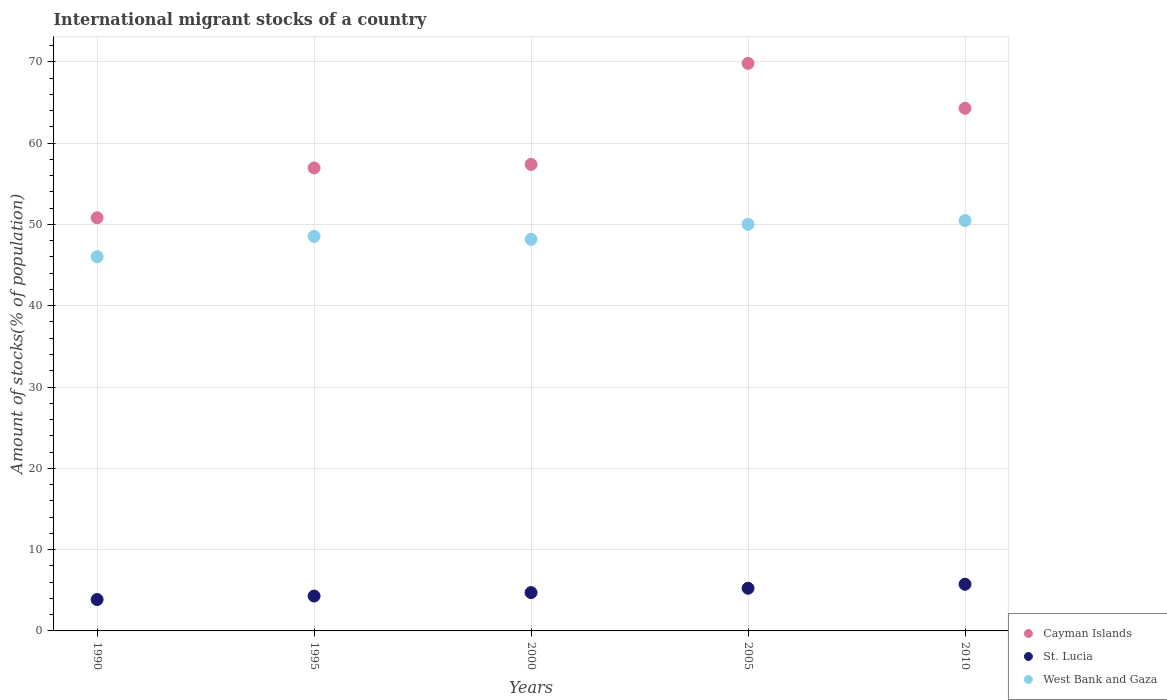Is the number of dotlines equal to the number of legend labels?
Provide a short and direct response. Yes. What is the amount of stocks in in West Bank and Gaza in 1995?
Keep it short and to the point. 48.53. Across all years, what is the maximum amount of stocks in in St. Lucia?
Offer a very short reply. 5.74. Across all years, what is the minimum amount of stocks in in St. Lucia?
Make the answer very short. 3.86. In which year was the amount of stocks in in Cayman Islands minimum?
Give a very brief answer. 1990. What is the total amount of stocks in in St. Lucia in the graph?
Keep it short and to the point. 23.85. What is the difference between the amount of stocks in in St. Lucia in 2000 and that in 2010?
Provide a succinct answer. -1.02. What is the difference between the amount of stocks in in St. Lucia in 2005 and the amount of stocks in in West Bank and Gaza in 2010?
Keep it short and to the point. -45.23. What is the average amount of stocks in in West Bank and Gaza per year?
Offer a terse response. 48.64. In the year 2010, what is the difference between the amount of stocks in in St. Lucia and amount of stocks in in West Bank and Gaza?
Your answer should be very brief. -44.74. In how many years, is the amount of stocks in in West Bank and Gaza greater than 12 %?
Your answer should be very brief. 5. What is the ratio of the amount of stocks in in Cayman Islands in 2000 to that in 2010?
Your answer should be very brief. 0.89. Is the difference between the amount of stocks in in St. Lucia in 1995 and 2010 greater than the difference between the amount of stocks in in West Bank and Gaza in 1995 and 2010?
Your answer should be compact. Yes. What is the difference between the highest and the second highest amount of stocks in in Cayman Islands?
Offer a very short reply. 5.53. What is the difference between the highest and the lowest amount of stocks in in Cayman Islands?
Provide a short and direct response. 18.98. Is it the case that in every year, the sum of the amount of stocks in in St. Lucia and amount of stocks in in West Bank and Gaza  is greater than the amount of stocks in in Cayman Islands?
Keep it short and to the point. No. Does the amount of stocks in in St. Lucia monotonically increase over the years?
Your response must be concise. Yes. Is the amount of stocks in in West Bank and Gaza strictly less than the amount of stocks in in Cayman Islands over the years?
Keep it short and to the point. Yes. How many years are there in the graph?
Your answer should be very brief. 5. What is the difference between two consecutive major ticks on the Y-axis?
Give a very brief answer. 10. Are the values on the major ticks of Y-axis written in scientific E-notation?
Provide a short and direct response. No. Does the graph contain any zero values?
Provide a succinct answer. No. Does the graph contain grids?
Offer a terse response. Yes. How many legend labels are there?
Offer a very short reply. 3. What is the title of the graph?
Offer a very short reply. International migrant stocks of a country. Does "Mozambique" appear as one of the legend labels in the graph?
Your answer should be very brief. No. What is the label or title of the X-axis?
Provide a short and direct response. Years. What is the label or title of the Y-axis?
Give a very brief answer. Amount of stocks(% of population). What is the Amount of stocks(% of population) of Cayman Islands in 1990?
Give a very brief answer. 50.83. What is the Amount of stocks(% of population) in St. Lucia in 1990?
Your answer should be compact. 3.86. What is the Amount of stocks(% of population) of West Bank and Gaza in 1990?
Offer a terse response. 46.03. What is the Amount of stocks(% of population) of Cayman Islands in 1995?
Your answer should be very brief. 56.95. What is the Amount of stocks(% of population) of St. Lucia in 1995?
Keep it short and to the point. 4.29. What is the Amount of stocks(% of population) in West Bank and Gaza in 1995?
Your answer should be compact. 48.53. What is the Amount of stocks(% of population) in Cayman Islands in 2000?
Your answer should be compact. 57.38. What is the Amount of stocks(% of population) of St. Lucia in 2000?
Give a very brief answer. 4.71. What is the Amount of stocks(% of population) of West Bank and Gaza in 2000?
Offer a terse response. 48.17. What is the Amount of stocks(% of population) of Cayman Islands in 2005?
Make the answer very short. 69.81. What is the Amount of stocks(% of population) in St. Lucia in 2005?
Provide a succinct answer. 5.25. What is the Amount of stocks(% of population) in West Bank and Gaza in 2005?
Offer a very short reply. 50.01. What is the Amount of stocks(% of population) in Cayman Islands in 2010?
Your response must be concise. 64.29. What is the Amount of stocks(% of population) of St. Lucia in 2010?
Your answer should be very brief. 5.74. What is the Amount of stocks(% of population) in West Bank and Gaza in 2010?
Your response must be concise. 50.48. Across all years, what is the maximum Amount of stocks(% of population) in Cayman Islands?
Your answer should be very brief. 69.81. Across all years, what is the maximum Amount of stocks(% of population) in St. Lucia?
Your response must be concise. 5.74. Across all years, what is the maximum Amount of stocks(% of population) in West Bank and Gaza?
Give a very brief answer. 50.48. Across all years, what is the minimum Amount of stocks(% of population) in Cayman Islands?
Offer a very short reply. 50.83. Across all years, what is the minimum Amount of stocks(% of population) in St. Lucia?
Ensure brevity in your answer.  3.86. Across all years, what is the minimum Amount of stocks(% of population) of West Bank and Gaza?
Provide a short and direct response. 46.03. What is the total Amount of stocks(% of population) of Cayman Islands in the graph?
Keep it short and to the point. 299.25. What is the total Amount of stocks(% of population) of St. Lucia in the graph?
Keep it short and to the point. 23.85. What is the total Amount of stocks(% of population) of West Bank and Gaza in the graph?
Offer a terse response. 243.22. What is the difference between the Amount of stocks(% of population) in Cayman Islands in 1990 and that in 1995?
Keep it short and to the point. -6.12. What is the difference between the Amount of stocks(% of population) of St. Lucia in 1990 and that in 1995?
Offer a terse response. -0.43. What is the difference between the Amount of stocks(% of population) in West Bank and Gaza in 1990 and that in 1995?
Make the answer very short. -2.5. What is the difference between the Amount of stocks(% of population) in Cayman Islands in 1990 and that in 2000?
Keep it short and to the point. -6.56. What is the difference between the Amount of stocks(% of population) of St. Lucia in 1990 and that in 2000?
Offer a terse response. -0.85. What is the difference between the Amount of stocks(% of population) in West Bank and Gaza in 1990 and that in 2000?
Keep it short and to the point. -2.14. What is the difference between the Amount of stocks(% of population) of Cayman Islands in 1990 and that in 2005?
Make the answer very short. -18.98. What is the difference between the Amount of stocks(% of population) in St. Lucia in 1990 and that in 2005?
Offer a very short reply. -1.39. What is the difference between the Amount of stocks(% of population) in West Bank and Gaza in 1990 and that in 2005?
Your answer should be very brief. -3.98. What is the difference between the Amount of stocks(% of population) in Cayman Islands in 1990 and that in 2010?
Provide a succinct answer. -13.46. What is the difference between the Amount of stocks(% of population) in St. Lucia in 1990 and that in 2010?
Your response must be concise. -1.88. What is the difference between the Amount of stocks(% of population) of West Bank and Gaza in 1990 and that in 2010?
Provide a short and direct response. -4.45. What is the difference between the Amount of stocks(% of population) in Cayman Islands in 1995 and that in 2000?
Your response must be concise. -0.43. What is the difference between the Amount of stocks(% of population) of St. Lucia in 1995 and that in 2000?
Your answer should be compact. -0.42. What is the difference between the Amount of stocks(% of population) in West Bank and Gaza in 1995 and that in 2000?
Ensure brevity in your answer.  0.36. What is the difference between the Amount of stocks(% of population) in Cayman Islands in 1995 and that in 2005?
Give a very brief answer. -12.86. What is the difference between the Amount of stocks(% of population) in St. Lucia in 1995 and that in 2005?
Offer a terse response. -0.96. What is the difference between the Amount of stocks(% of population) of West Bank and Gaza in 1995 and that in 2005?
Make the answer very short. -1.48. What is the difference between the Amount of stocks(% of population) of Cayman Islands in 1995 and that in 2010?
Provide a succinct answer. -7.34. What is the difference between the Amount of stocks(% of population) in St. Lucia in 1995 and that in 2010?
Offer a terse response. -1.45. What is the difference between the Amount of stocks(% of population) of West Bank and Gaza in 1995 and that in 2010?
Your answer should be very brief. -1.95. What is the difference between the Amount of stocks(% of population) of Cayman Islands in 2000 and that in 2005?
Make the answer very short. -12.43. What is the difference between the Amount of stocks(% of population) of St. Lucia in 2000 and that in 2005?
Your answer should be compact. -0.53. What is the difference between the Amount of stocks(% of population) in West Bank and Gaza in 2000 and that in 2005?
Your response must be concise. -1.84. What is the difference between the Amount of stocks(% of population) of Cayman Islands in 2000 and that in 2010?
Your response must be concise. -6.9. What is the difference between the Amount of stocks(% of population) in St. Lucia in 2000 and that in 2010?
Keep it short and to the point. -1.02. What is the difference between the Amount of stocks(% of population) of West Bank and Gaza in 2000 and that in 2010?
Ensure brevity in your answer.  -2.31. What is the difference between the Amount of stocks(% of population) of Cayman Islands in 2005 and that in 2010?
Your answer should be very brief. 5.53. What is the difference between the Amount of stocks(% of population) of St. Lucia in 2005 and that in 2010?
Provide a succinct answer. -0.49. What is the difference between the Amount of stocks(% of population) of West Bank and Gaza in 2005 and that in 2010?
Ensure brevity in your answer.  -0.47. What is the difference between the Amount of stocks(% of population) of Cayman Islands in 1990 and the Amount of stocks(% of population) of St. Lucia in 1995?
Your answer should be very brief. 46.53. What is the difference between the Amount of stocks(% of population) in Cayman Islands in 1990 and the Amount of stocks(% of population) in West Bank and Gaza in 1995?
Offer a terse response. 2.29. What is the difference between the Amount of stocks(% of population) in St. Lucia in 1990 and the Amount of stocks(% of population) in West Bank and Gaza in 1995?
Your response must be concise. -44.67. What is the difference between the Amount of stocks(% of population) of Cayman Islands in 1990 and the Amount of stocks(% of population) of St. Lucia in 2000?
Provide a short and direct response. 46.11. What is the difference between the Amount of stocks(% of population) in Cayman Islands in 1990 and the Amount of stocks(% of population) in West Bank and Gaza in 2000?
Offer a terse response. 2.65. What is the difference between the Amount of stocks(% of population) of St. Lucia in 1990 and the Amount of stocks(% of population) of West Bank and Gaza in 2000?
Your answer should be compact. -44.31. What is the difference between the Amount of stocks(% of population) in Cayman Islands in 1990 and the Amount of stocks(% of population) in St. Lucia in 2005?
Your response must be concise. 45.58. What is the difference between the Amount of stocks(% of population) in Cayman Islands in 1990 and the Amount of stocks(% of population) in West Bank and Gaza in 2005?
Keep it short and to the point. 0.81. What is the difference between the Amount of stocks(% of population) of St. Lucia in 1990 and the Amount of stocks(% of population) of West Bank and Gaza in 2005?
Keep it short and to the point. -46.15. What is the difference between the Amount of stocks(% of population) in Cayman Islands in 1990 and the Amount of stocks(% of population) in St. Lucia in 2010?
Offer a very short reply. 45.09. What is the difference between the Amount of stocks(% of population) of Cayman Islands in 1990 and the Amount of stocks(% of population) of West Bank and Gaza in 2010?
Provide a short and direct response. 0.35. What is the difference between the Amount of stocks(% of population) in St. Lucia in 1990 and the Amount of stocks(% of population) in West Bank and Gaza in 2010?
Offer a terse response. -46.62. What is the difference between the Amount of stocks(% of population) in Cayman Islands in 1995 and the Amount of stocks(% of population) in St. Lucia in 2000?
Provide a succinct answer. 52.23. What is the difference between the Amount of stocks(% of population) of Cayman Islands in 1995 and the Amount of stocks(% of population) of West Bank and Gaza in 2000?
Ensure brevity in your answer.  8.78. What is the difference between the Amount of stocks(% of population) in St. Lucia in 1995 and the Amount of stocks(% of population) in West Bank and Gaza in 2000?
Ensure brevity in your answer.  -43.88. What is the difference between the Amount of stocks(% of population) in Cayman Islands in 1995 and the Amount of stocks(% of population) in St. Lucia in 2005?
Your answer should be very brief. 51.7. What is the difference between the Amount of stocks(% of population) of Cayman Islands in 1995 and the Amount of stocks(% of population) of West Bank and Gaza in 2005?
Provide a succinct answer. 6.94. What is the difference between the Amount of stocks(% of population) of St. Lucia in 1995 and the Amount of stocks(% of population) of West Bank and Gaza in 2005?
Offer a terse response. -45.72. What is the difference between the Amount of stocks(% of population) of Cayman Islands in 1995 and the Amount of stocks(% of population) of St. Lucia in 2010?
Offer a terse response. 51.21. What is the difference between the Amount of stocks(% of population) of Cayman Islands in 1995 and the Amount of stocks(% of population) of West Bank and Gaza in 2010?
Ensure brevity in your answer.  6.47. What is the difference between the Amount of stocks(% of population) of St. Lucia in 1995 and the Amount of stocks(% of population) of West Bank and Gaza in 2010?
Your response must be concise. -46.19. What is the difference between the Amount of stocks(% of population) of Cayman Islands in 2000 and the Amount of stocks(% of population) of St. Lucia in 2005?
Provide a succinct answer. 52.14. What is the difference between the Amount of stocks(% of population) in Cayman Islands in 2000 and the Amount of stocks(% of population) in West Bank and Gaza in 2005?
Offer a terse response. 7.37. What is the difference between the Amount of stocks(% of population) of St. Lucia in 2000 and the Amount of stocks(% of population) of West Bank and Gaza in 2005?
Provide a succinct answer. -45.3. What is the difference between the Amount of stocks(% of population) in Cayman Islands in 2000 and the Amount of stocks(% of population) in St. Lucia in 2010?
Offer a terse response. 51.64. What is the difference between the Amount of stocks(% of population) of Cayman Islands in 2000 and the Amount of stocks(% of population) of West Bank and Gaza in 2010?
Ensure brevity in your answer.  6.9. What is the difference between the Amount of stocks(% of population) of St. Lucia in 2000 and the Amount of stocks(% of population) of West Bank and Gaza in 2010?
Give a very brief answer. -45.76. What is the difference between the Amount of stocks(% of population) of Cayman Islands in 2005 and the Amount of stocks(% of population) of St. Lucia in 2010?
Ensure brevity in your answer.  64.07. What is the difference between the Amount of stocks(% of population) in Cayman Islands in 2005 and the Amount of stocks(% of population) in West Bank and Gaza in 2010?
Offer a very short reply. 19.33. What is the difference between the Amount of stocks(% of population) in St. Lucia in 2005 and the Amount of stocks(% of population) in West Bank and Gaza in 2010?
Provide a succinct answer. -45.23. What is the average Amount of stocks(% of population) of Cayman Islands per year?
Provide a succinct answer. 59.85. What is the average Amount of stocks(% of population) in St. Lucia per year?
Make the answer very short. 4.77. What is the average Amount of stocks(% of population) in West Bank and Gaza per year?
Give a very brief answer. 48.64. In the year 1990, what is the difference between the Amount of stocks(% of population) of Cayman Islands and Amount of stocks(% of population) of St. Lucia?
Offer a terse response. 46.96. In the year 1990, what is the difference between the Amount of stocks(% of population) in Cayman Islands and Amount of stocks(% of population) in West Bank and Gaza?
Make the answer very short. 4.79. In the year 1990, what is the difference between the Amount of stocks(% of population) of St. Lucia and Amount of stocks(% of population) of West Bank and Gaza?
Offer a terse response. -42.17. In the year 1995, what is the difference between the Amount of stocks(% of population) of Cayman Islands and Amount of stocks(% of population) of St. Lucia?
Offer a very short reply. 52.66. In the year 1995, what is the difference between the Amount of stocks(% of population) of Cayman Islands and Amount of stocks(% of population) of West Bank and Gaza?
Give a very brief answer. 8.42. In the year 1995, what is the difference between the Amount of stocks(% of population) of St. Lucia and Amount of stocks(% of population) of West Bank and Gaza?
Give a very brief answer. -44.24. In the year 2000, what is the difference between the Amount of stocks(% of population) of Cayman Islands and Amount of stocks(% of population) of St. Lucia?
Your response must be concise. 52.67. In the year 2000, what is the difference between the Amount of stocks(% of population) of Cayman Islands and Amount of stocks(% of population) of West Bank and Gaza?
Offer a terse response. 9.21. In the year 2000, what is the difference between the Amount of stocks(% of population) in St. Lucia and Amount of stocks(% of population) in West Bank and Gaza?
Your answer should be very brief. -43.46. In the year 2005, what is the difference between the Amount of stocks(% of population) in Cayman Islands and Amount of stocks(% of population) in St. Lucia?
Offer a terse response. 64.56. In the year 2005, what is the difference between the Amount of stocks(% of population) of Cayman Islands and Amount of stocks(% of population) of West Bank and Gaza?
Your answer should be compact. 19.8. In the year 2005, what is the difference between the Amount of stocks(% of population) in St. Lucia and Amount of stocks(% of population) in West Bank and Gaza?
Your response must be concise. -44.76. In the year 2010, what is the difference between the Amount of stocks(% of population) of Cayman Islands and Amount of stocks(% of population) of St. Lucia?
Your answer should be compact. 58.55. In the year 2010, what is the difference between the Amount of stocks(% of population) of Cayman Islands and Amount of stocks(% of population) of West Bank and Gaza?
Make the answer very short. 13.81. In the year 2010, what is the difference between the Amount of stocks(% of population) of St. Lucia and Amount of stocks(% of population) of West Bank and Gaza?
Keep it short and to the point. -44.74. What is the ratio of the Amount of stocks(% of population) in Cayman Islands in 1990 to that in 1995?
Offer a very short reply. 0.89. What is the ratio of the Amount of stocks(% of population) of St. Lucia in 1990 to that in 1995?
Your answer should be very brief. 0.9. What is the ratio of the Amount of stocks(% of population) of West Bank and Gaza in 1990 to that in 1995?
Offer a terse response. 0.95. What is the ratio of the Amount of stocks(% of population) in Cayman Islands in 1990 to that in 2000?
Your answer should be compact. 0.89. What is the ratio of the Amount of stocks(% of population) in St. Lucia in 1990 to that in 2000?
Keep it short and to the point. 0.82. What is the ratio of the Amount of stocks(% of population) in West Bank and Gaza in 1990 to that in 2000?
Provide a short and direct response. 0.96. What is the ratio of the Amount of stocks(% of population) in Cayman Islands in 1990 to that in 2005?
Provide a succinct answer. 0.73. What is the ratio of the Amount of stocks(% of population) of St. Lucia in 1990 to that in 2005?
Provide a short and direct response. 0.74. What is the ratio of the Amount of stocks(% of population) in West Bank and Gaza in 1990 to that in 2005?
Your response must be concise. 0.92. What is the ratio of the Amount of stocks(% of population) in Cayman Islands in 1990 to that in 2010?
Your answer should be compact. 0.79. What is the ratio of the Amount of stocks(% of population) of St. Lucia in 1990 to that in 2010?
Offer a terse response. 0.67. What is the ratio of the Amount of stocks(% of population) of West Bank and Gaza in 1990 to that in 2010?
Offer a very short reply. 0.91. What is the ratio of the Amount of stocks(% of population) in Cayman Islands in 1995 to that in 2000?
Ensure brevity in your answer.  0.99. What is the ratio of the Amount of stocks(% of population) of St. Lucia in 1995 to that in 2000?
Ensure brevity in your answer.  0.91. What is the ratio of the Amount of stocks(% of population) in West Bank and Gaza in 1995 to that in 2000?
Offer a very short reply. 1.01. What is the ratio of the Amount of stocks(% of population) in Cayman Islands in 1995 to that in 2005?
Keep it short and to the point. 0.82. What is the ratio of the Amount of stocks(% of population) of St. Lucia in 1995 to that in 2005?
Offer a very short reply. 0.82. What is the ratio of the Amount of stocks(% of population) of West Bank and Gaza in 1995 to that in 2005?
Your answer should be very brief. 0.97. What is the ratio of the Amount of stocks(% of population) in Cayman Islands in 1995 to that in 2010?
Offer a very short reply. 0.89. What is the ratio of the Amount of stocks(% of population) in St. Lucia in 1995 to that in 2010?
Your response must be concise. 0.75. What is the ratio of the Amount of stocks(% of population) of West Bank and Gaza in 1995 to that in 2010?
Provide a short and direct response. 0.96. What is the ratio of the Amount of stocks(% of population) in Cayman Islands in 2000 to that in 2005?
Your answer should be very brief. 0.82. What is the ratio of the Amount of stocks(% of population) in St. Lucia in 2000 to that in 2005?
Offer a terse response. 0.9. What is the ratio of the Amount of stocks(% of population) of West Bank and Gaza in 2000 to that in 2005?
Offer a very short reply. 0.96. What is the ratio of the Amount of stocks(% of population) in Cayman Islands in 2000 to that in 2010?
Offer a terse response. 0.89. What is the ratio of the Amount of stocks(% of population) of St. Lucia in 2000 to that in 2010?
Your answer should be very brief. 0.82. What is the ratio of the Amount of stocks(% of population) of West Bank and Gaza in 2000 to that in 2010?
Provide a short and direct response. 0.95. What is the ratio of the Amount of stocks(% of population) of Cayman Islands in 2005 to that in 2010?
Make the answer very short. 1.09. What is the ratio of the Amount of stocks(% of population) in St. Lucia in 2005 to that in 2010?
Your response must be concise. 0.91. What is the difference between the highest and the second highest Amount of stocks(% of population) in Cayman Islands?
Keep it short and to the point. 5.53. What is the difference between the highest and the second highest Amount of stocks(% of population) of St. Lucia?
Your response must be concise. 0.49. What is the difference between the highest and the second highest Amount of stocks(% of population) of West Bank and Gaza?
Give a very brief answer. 0.47. What is the difference between the highest and the lowest Amount of stocks(% of population) in Cayman Islands?
Your response must be concise. 18.98. What is the difference between the highest and the lowest Amount of stocks(% of population) of St. Lucia?
Offer a very short reply. 1.88. What is the difference between the highest and the lowest Amount of stocks(% of population) of West Bank and Gaza?
Offer a terse response. 4.45. 